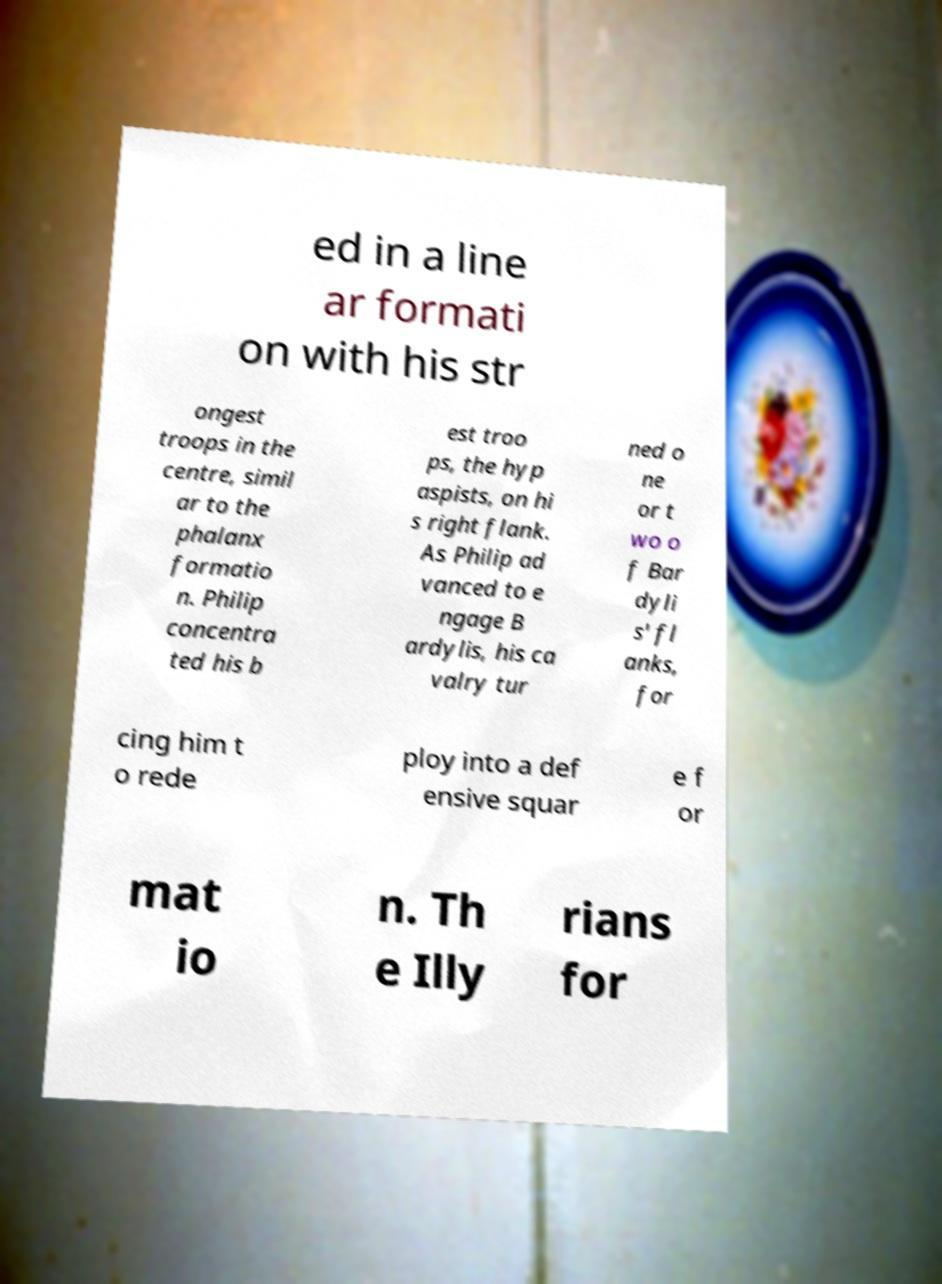There's text embedded in this image that I need extracted. Can you transcribe it verbatim? ed in a line ar formati on with his str ongest troops in the centre, simil ar to the phalanx formatio n. Philip concentra ted his b est troo ps, the hyp aspists, on hi s right flank. As Philip ad vanced to e ngage B ardylis, his ca valry tur ned o ne or t wo o f Bar dyli s' fl anks, for cing him t o rede ploy into a def ensive squar e f or mat io n. Th e Illy rians for 